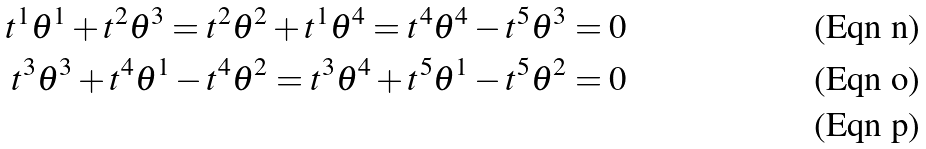<formula> <loc_0><loc_0><loc_500><loc_500>t ^ { 1 } \theta ^ { 1 } + t ^ { 2 } \theta ^ { 3 } = t ^ { 2 } \theta ^ { 2 } + t ^ { 1 } \theta ^ { 4 } = t ^ { 4 } \theta ^ { 4 } - t ^ { 5 } \theta ^ { 3 } = 0 \\ t ^ { 3 } \theta ^ { 3 } + t ^ { 4 } \theta ^ { 1 } - t ^ { 4 } \theta ^ { 2 } = t ^ { 3 } \theta ^ { 4 } + t ^ { 5 } \theta ^ { 1 } - t ^ { 5 } \theta ^ { 2 } = 0 \\</formula> 